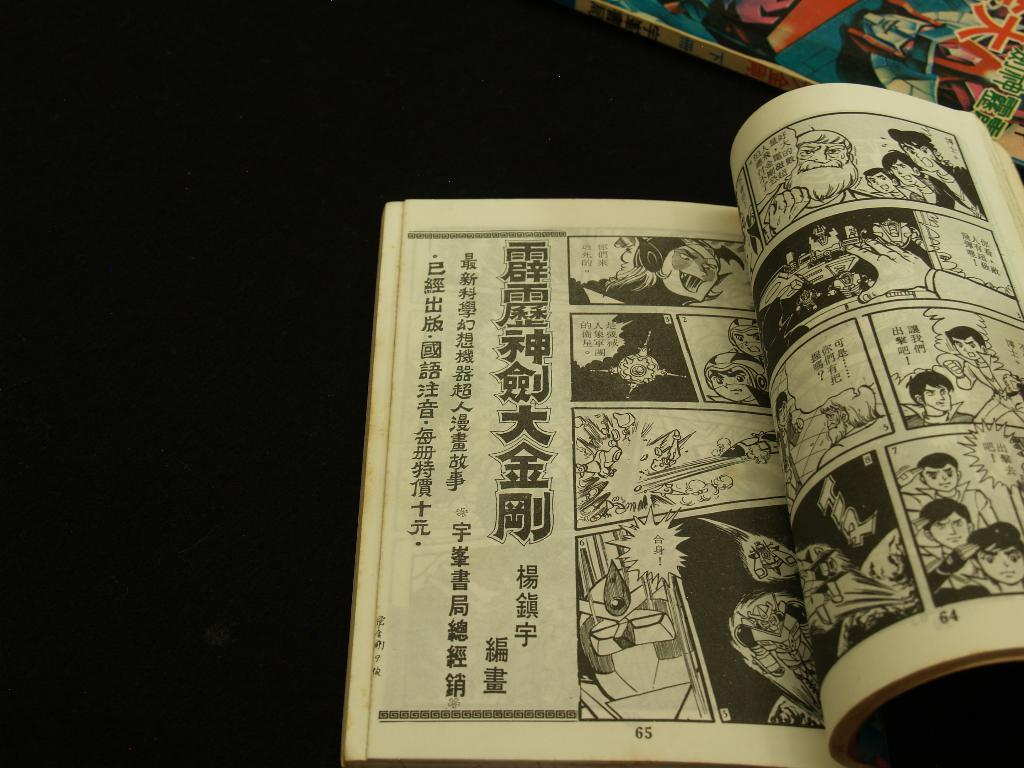<image>
Give a short and clear explanation of the subsequent image. Asian comic book strip open on page 65 and 64. 